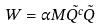<formula> <loc_0><loc_0><loc_500><loc_500>W = \alpha M \tilde { Q ^ { c } } \tilde { Q }</formula> 